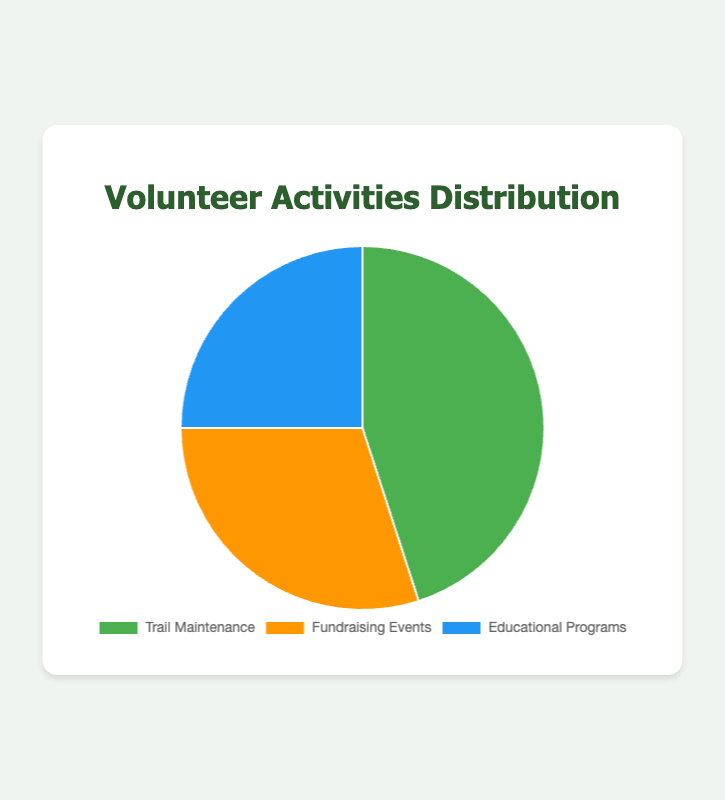What percentage of volunteer activities is dedicated to Trail Maintenance? Trail Maintenance accounts for 45% of volunteer activities as per the pie chart.
Answer: 45% How much greater is the percentage of Trail Maintenance compared to Educational Programs? The percentage for Trail Maintenance is 45% and for Educational Programs is 25%. Subtracting these values gives 45% - 25% = 20%.
Answer: 20% Which volunteer activity receives the least amount of volunteer effort? Educational Programs have the smallest percentage at 25%, making it the activity receiving the least effort.
Answer: Educational Programs What is the combined percentage of Trail Maintenance and Fundraising Events? Adding the percentages for Trail Maintenance (45%) and Fundraising Events (30%) gives 45% + 30% = 75%.
Answer: 75% Compare the sum of Educational Programs and Fundraising Events with Trail Maintenance. Which one is larger? The sum of Educational Programs (25%) and Fundraising Events (30%) is 25% + 30% = 55%. This combined value is greater than the percentage for Trail Maintenance alone (45%).
Answer: The sum (55%) What is the proportion of Fundraising Events compared to the total percentage of all activities? The total percentage of all activities sums up to 100%, and Fundraising Events account for 30% of this total. Therefore, the proportion is 30%.
Answer: 30% What color represents Trail Maintenance in the pie chart? Trail Maintenance is represented by green in the pie chart.
Answer: Green If you were to increase the percentage of Fundraising Events by 5%, how would that affect the total percentage distribution? Increasing Fundraising Events to 35% would alter the distribution, requiring a corresponding decrease in another category to maintain the total 100%. For example, if Trail Maintenance decreases to 40%, the new distribution would be Trail Maintenance: 40%, Fundraising Events: 35%, Educational Programs: 25%.
Answer: Alter percentages Which volunteer activity has the second largest percentage? Fundraising Events are the second largest with 30%.
Answer: Fundraising Events If we combined the percentages of Educational Programs and a half of Fundraising Events, what would the new total be? Half of Fundraising Events is 30% / 2 = 15%. Adding this to Educational Programs (25%) gives 25% + 15% = 40%.
Answer: 40% 